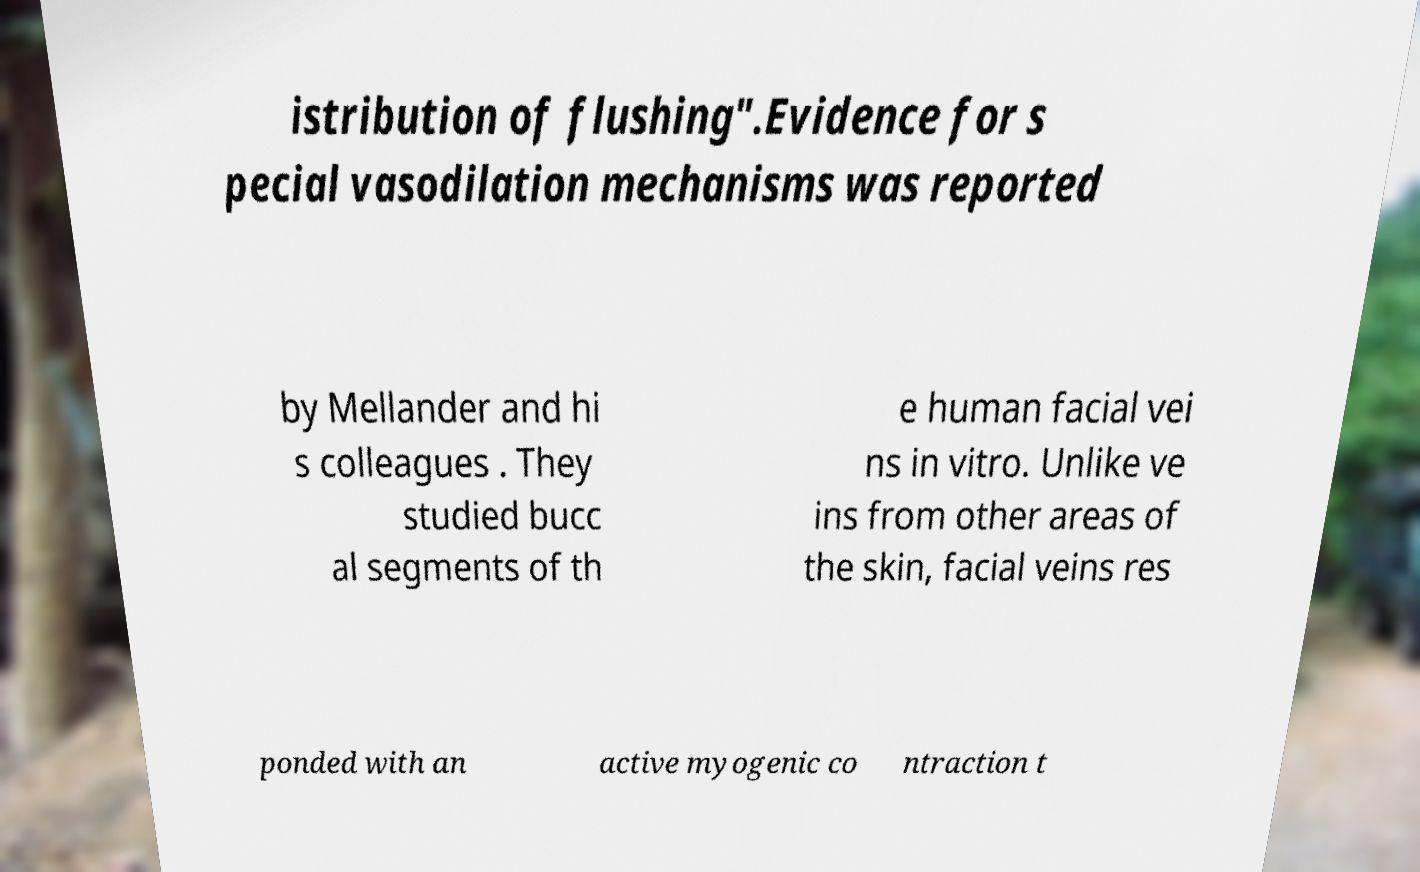I need the written content from this picture converted into text. Can you do that? istribution of flushing".Evidence for s pecial vasodilation mechanisms was reported by Mellander and hi s colleagues . They studied bucc al segments of th e human facial vei ns in vitro. Unlike ve ins from other areas of the skin, facial veins res ponded with an active myogenic co ntraction t 